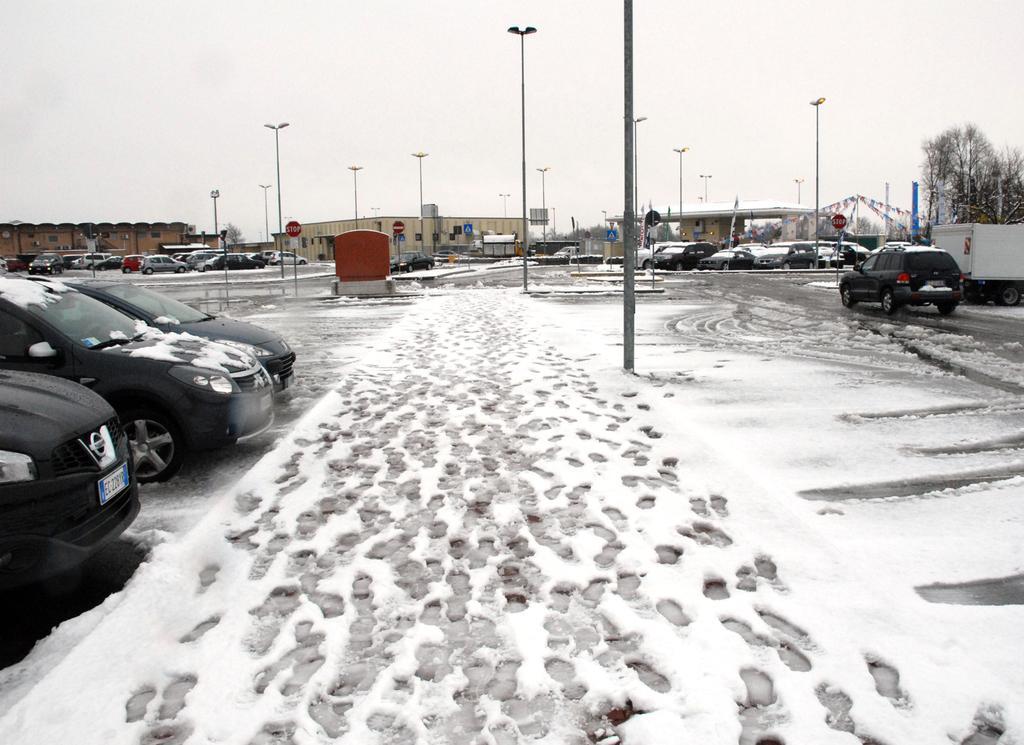Could you give a brief overview of what you see in this image? This image is taken outdoors. On the left side of the image a few cars are parked on the ground. At the bottom of the image there is a ground covered with snow. On the right side of the image a car is moving on the road and a few cars are parked on the ground. In the background there are a few houses, poles, street lights and trees. At the top of the image there is a sky. 